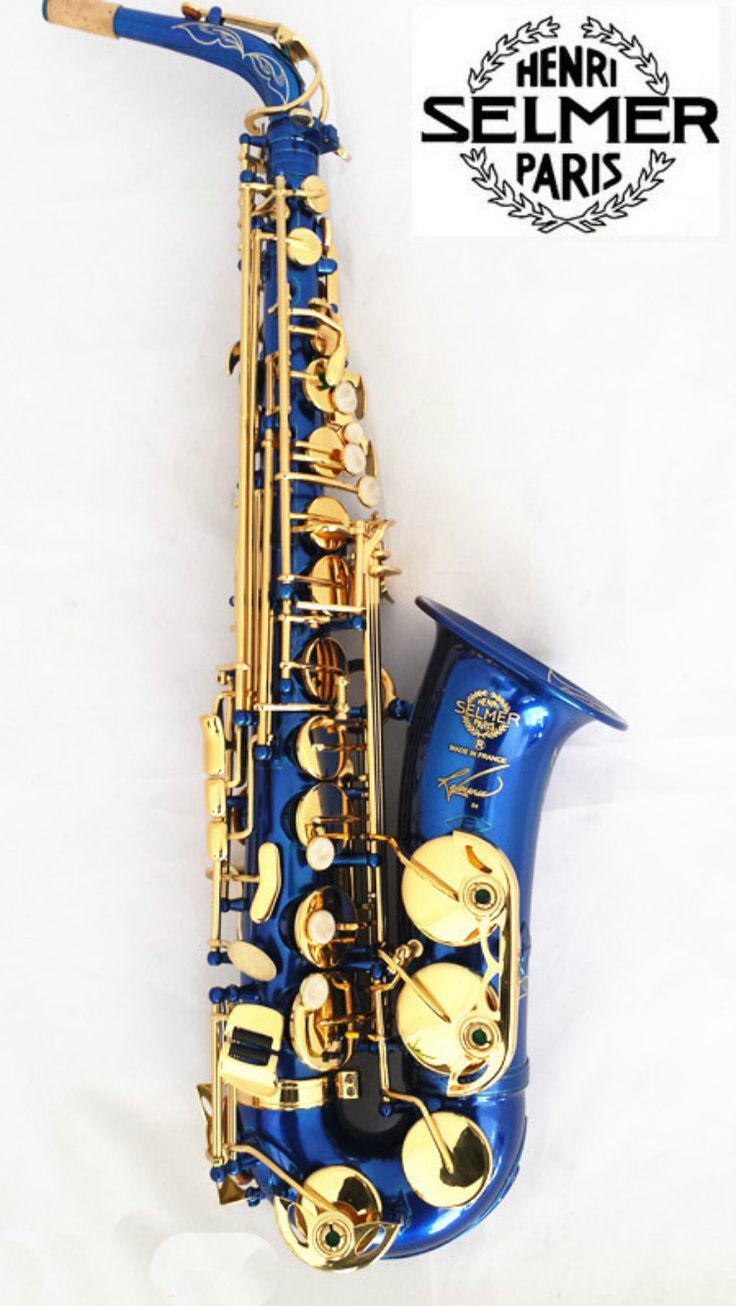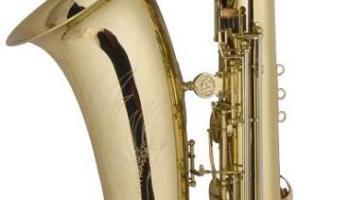The first image is the image on the left, the second image is the image on the right. Analyze the images presented: Is the assertion "More than three different types of instruments are shown in one photo with one of them being a saxophone that is straight." valid? Answer yes or no. No. The first image is the image on the left, the second image is the image on the right. Considering the images on both sides, is "An image shows a row of at least four instruments, and the one on the far left does not have an upturned bell." valid? Answer yes or no. No. 